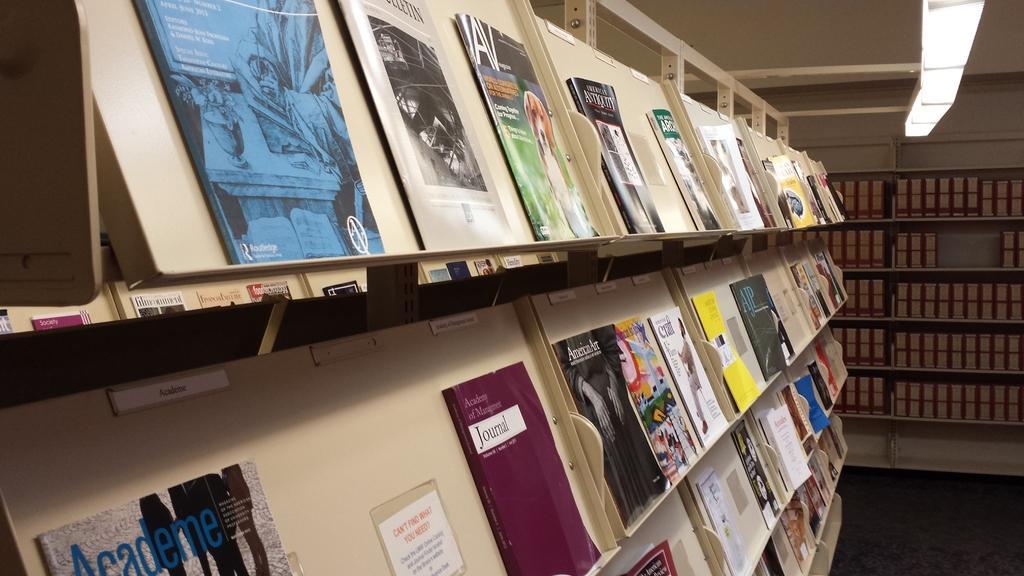Can you describe this image briefly? This picture is clicked inside the room. On the left we can see an object seems to be the wooden rack and we can see many number of books placed in the rack and we can see the text and pictures of many other objects on the covers of books. In the background we can see the wall and the racks containing some objects seems to be the books. In the top right corner we can see a white color object. 